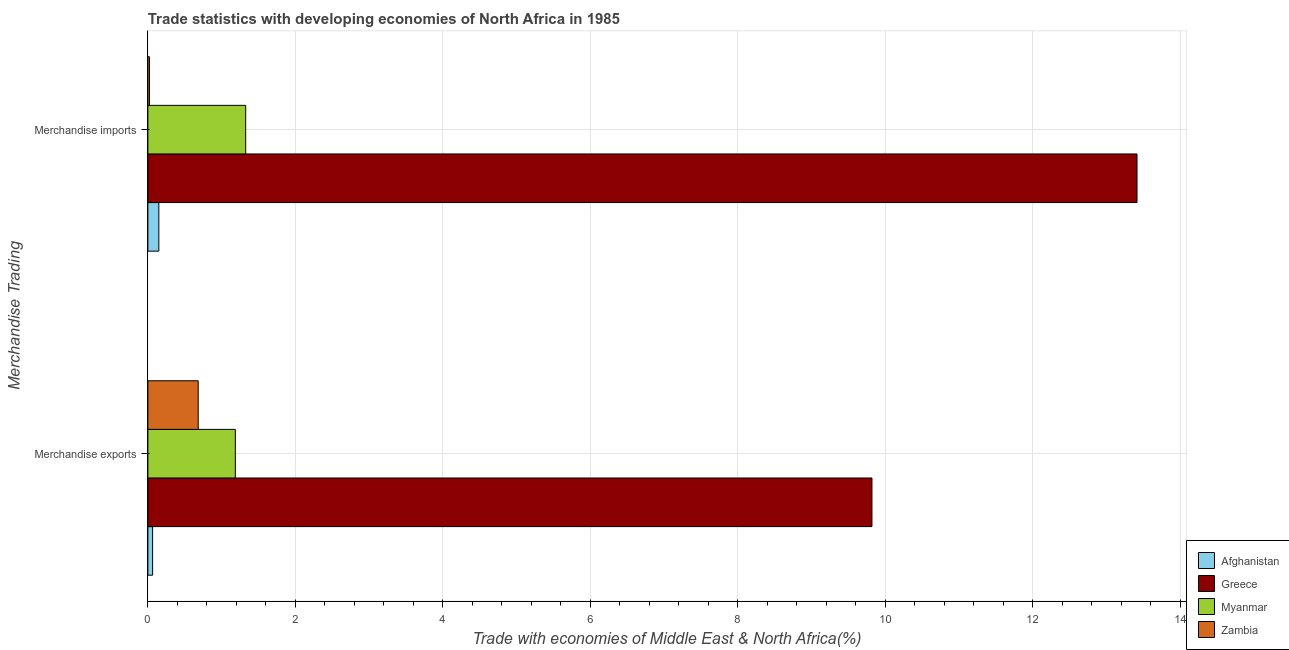How many groups of bars are there?
Give a very brief answer. 2. How many bars are there on the 2nd tick from the bottom?
Your answer should be very brief. 4. What is the label of the 1st group of bars from the top?
Provide a short and direct response. Merchandise imports. What is the merchandise imports in Zambia?
Make the answer very short. 0.02. Across all countries, what is the maximum merchandise imports?
Ensure brevity in your answer.  13.41. Across all countries, what is the minimum merchandise exports?
Your response must be concise. 0.06. In which country was the merchandise imports maximum?
Give a very brief answer. Greece. In which country was the merchandise imports minimum?
Provide a succinct answer. Zambia. What is the total merchandise imports in the graph?
Provide a short and direct response. 14.91. What is the difference between the merchandise imports in Myanmar and that in Greece?
Provide a succinct answer. -12.08. What is the difference between the merchandise exports in Greece and the merchandise imports in Afghanistan?
Your answer should be compact. 9.67. What is the average merchandise exports per country?
Offer a terse response. 2.94. What is the difference between the merchandise exports and merchandise imports in Afghanistan?
Offer a very short reply. -0.08. What is the ratio of the merchandise exports in Afghanistan to that in Greece?
Provide a succinct answer. 0.01. What does the 4th bar from the bottom in Merchandise exports represents?
Provide a short and direct response. Zambia. Does the graph contain grids?
Offer a very short reply. Yes. How many legend labels are there?
Offer a very short reply. 4. What is the title of the graph?
Your answer should be very brief. Trade statistics with developing economies of North Africa in 1985. What is the label or title of the X-axis?
Keep it short and to the point. Trade with economies of Middle East & North Africa(%). What is the label or title of the Y-axis?
Give a very brief answer. Merchandise Trading. What is the Trade with economies of Middle East & North Africa(%) in Afghanistan in Merchandise exports?
Provide a succinct answer. 0.06. What is the Trade with economies of Middle East & North Africa(%) in Greece in Merchandise exports?
Make the answer very short. 9.82. What is the Trade with economies of Middle East & North Africa(%) in Myanmar in Merchandise exports?
Your response must be concise. 1.19. What is the Trade with economies of Middle East & North Africa(%) of Zambia in Merchandise exports?
Your response must be concise. 0.68. What is the Trade with economies of Middle East & North Africa(%) in Afghanistan in Merchandise imports?
Your answer should be compact. 0.15. What is the Trade with economies of Middle East & North Africa(%) of Greece in Merchandise imports?
Provide a succinct answer. 13.41. What is the Trade with economies of Middle East & North Africa(%) of Myanmar in Merchandise imports?
Your response must be concise. 1.33. What is the Trade with economies of Middle East & North Africa(%) in Zambia in Merchandise imports?
Give a very brief answer. 0.02. Across all Merchandise Trading, what is the maximum Trade with economies of Middle East & North Africa(%) of Afghanistan?
Your response must be concise. 0.15. Across all Merchandise Trading, what is the maximum Trade with economies of Middle East & North Africa(%) of Greece?
Provide a short and direct response. 13.41. Across all Merchandise Trading, what is the maximum Trade with economies of Middle East & North Africa(%) in Myanmar?
Ensure brevity in your answer.  1.33. Across all Merchandise Trading, what is the maximum Trade with economies of Middle East & North Africa(%) of Zambia?
Provide a short and direct response. 0.68. Across all Merchandise Trading, what is the minimum Trade with economies of Middle East & North Africa(%) of Afghanistan?
Offer a terse response. 0.06. Across all Merchandise Trading, what is the minimum Trade with economies of Middle East & North Africa(%) of Greece?
Provide a short and direct response. 9.82. Across all Merchandise Trading, what is the minimum Trade with economies of Middle East & North Africa(%) in Myanmar?
Your response must be concise. 1.19. Across all Merchandise Trading, what is the minimum Trade with economies of Middle East & North Africa(%) in Zambia?
Offer a very short reply. 0.02. What is the total Trade with economies of Middle East & North Africa(%) of Afghanistan in the graph?
Offer a terse response. 0.21. What is the total Trade with economies of Middle East & North Africa(%) in Greece in the graph?
Keep it short and to the point. 23.23. What is the total Trade with economies of Middle East & North Africa(%) in Myanmar in the graph?
Offer a terse response. 2.51. What is the total Trade with economies of Middle East & North Africa(%) in Zambia in the graph?
Your answer should be very brief. 0.7. What is the difference between the Trade with economies of Middle East & North Africa(%) in Afghanistan in Merchandise exports and that in Merchandise imports?
Provide a succinct answer. -0.08. What is the difference between the Trade with economies of Middle East & North Africa(%) in Greece in Merchandise exports and that in Merchandise imports?
Offer a terse response. -3.59. What is the difference between the Trade with economies of Middle East & North Africa(%) of Myanmar in Merchandise exports and that in Merchandise imports?
Ensure brevity in your answer.  -0.14. What is the difference between the Trade with economies of Middle East & North Africa(%) of Zambia in Merchandise exports and that in Merchandise imports?
Your answer should be very brief. 0.66. What is the difference between the Trade with economies of Middle East & North Africa(%) in Afghanistan in Merchandise exports and the Trade with economies of Middle East & North Africa(%) in Greece in Merchandise imports?
Give a very brief answer. -13.35. What is the difference between the Trade with economies of Middle East & North Africa(%) of Afghanistan in Merchandise exports and the Trade with economies of Middle East & North Africa(%) of Myanmar in Merchandise imports?
Provide a short and direct response. -1.26. What is the difference between the Trade with economies of Middle East & North Africa(%) of Afghanistan in Merchandise exports and the Trade with economies of Middle East & North Africa(%) of Zambia in Merchandise imports?
Your response must be concise. 0.04. What is the difference between the Trade with economies of Middle East & North Africa(%) of Greece in Merchandise exports and the Trade with economies of Middle East & North Africa(%) of Myanmar in Merchandise imports?
Your answer should be compact. 8.49. What is the difference between the Trade with economies of Middle East & North Africa(%) of Greece in Merchandise exports and the Trade with economies of Middle East & North Africa(%) of Zambia in Merchandise imports?
Ensure brevity in your answer.  9.8. What is the difference between the Trade with economies of Middle East & North Africa(%) of Myanmar in Merchandise exports and the Trade with economies of Middle East & North Africa(%) of Zambia in Merchandise imports?
Make the answer very short. 1.16. What is the average Trade with economies of Middle East & North Africa(%) in Afghanistan per Merchandise Trading?
Keep it short and to the point. 0.11. What is the average Trade with economies of Middle East & North Africa(%) of Greece per Merchandise Trading?
Your answer should be compact. 11.61. What is the average Trade with economies of Middle East & North Africa(%) of Myanmar per Merchandise Trading?
Offer a terse response. 1.26. What is the average Trade with economies of Middle East & North Africa(%) of Zambia per Merchandise Trading?
Provide a succinct answer. 0.35. What is the difference between the Trade with economies of Middle East & North Africa(%) of Afghanistan and Trade with economies of Middle East & North Africa(%) of Greece in Merchandise exports?
Provide a succinct answer. -9.75. What is the difference between the Trade with economies of Middle East & North Africa(%) of Afghanistan and Trade with economies of Middle East & North Africa(%) of Myanmar in Merchandise exports?
Offer a very short reply. -1.12. What is the difference between the Trade with economies of Middle East & North Africa(%) of Afghanistan and Trade with economies of Middle East & North Africa(%) of Zambia in Merchandise exports?
Offer a terse response. -0.62. What is the difference between the Trade with economies of Middle East & North Africa(%) of Greece and Trade with economies of Middle East & North Africa(%) of Myanmar in Merchandise exports?
Ensure brevity in your answer.  8.63. What is the difference between the Trade with economies of Middle East & North Africa(%) in Greece and Trade with economies of Middle East & North Africa(%) in Zambia in Merchandise exports?
Keep it short and to the point. 9.13. What is the difference between the Trade with economies of Middle East & North Africa(%) in Myanmar and Trade with economies of Middle East & North Africa(%) in Zambia in Merchandise exports?
Offer a terse response. 0.5. What is the difference between the Trade with economies of Middle East & North Africa(%) of Afghanistan and Trade with economies of Middle East & North Africa(%) of Greece in Merchandise imports?
Provide a short and direct response. -13.26. What is the difference between the Trade with economies of Middle East & North Africa(%) of Afghanistan and Trade with economies of Middle East & North Africa(%) of Myanmar in Merchandise imports?
Your response must be concise. -1.18. What is the difference between the Trade with economies of Middle East & North Africa(%) in Afghanistan and Trade with economies of Middle East & North Africa(%) in Zambia in Merchandise imports?
Offer a terse response. 0.13. What is the difference between the Trade with economies of Middle East & North Africa(%) in Greece and Trade with economies of Middle East & North Africa(%) in Myanmar in Merchandise imports?
Ensure brevity in your answer.  12.08. What is the difference between the Trade with economies of Middle East & North Africa(%) in Greece and Trade with economies of Middle East & North Africa(%) in Zambia in Merchandise imports?
Provide a short and direct response. 13.39. What is the difference between the Trade with economies of Middle East & North Africa(%) of Myanmar and Trade with economies of Middle East & North Africa(%) of Zambia in Merchandise imports?
Your answer should be very brief. 1.3. What is the ratio of the Trade with economies of Middle East & North Africa(%) of Afghanistan in Merchandise exports to that in Merchandise imports?
Offer a terse response. 0.43. What is the ratio of the Trade with economies of Middle East & North Africa(%) in Greece in Merchandise exports to that in Merchandise imports?
Your answer should be very brief. 0.73. What is the ratio of the Trade with economies of Middle East & North Africa(%) in Myanmar in Merchandise exports to that in Merchandise imports?
Your answer should be compact. 0.89. What is the ratio of the Trade with economies of Middle East & North Africa(%) of Zambia in Merchandise exports to that in Merchandise imports?
Ensure brevity in your answer.  31.85. What is the difference between the highest and the second highest Trade with economies of Middle East & North Africa(%) of Afghanistan?
Ensure brevity in your answer.  0.08. What is the difference between the highest and the second highest Trade with economies of Middle East & North Africa(%) of Greece?
Make the answer very short. 3.59. What is the difference between the highest and the second highest Trade with economies of Middle East & North Africa(%) in Myanmar?
Offer a very short reply. 0.14. What is the difference between the highest and the second highest Trade with economies of Middle East & North Africa(%) in Zambia?
Keep it short and to the point. 0.66. What is the difference between the highest and the lowest Trade with economies of Middle East & North Africa(%) of Afghanistan?
Ensure brevity in your answer.  0.08. What is the difference between the highest and the lowest Trade with economies of Middle East & North Africa(%) of Greece?
Make the answer very short. 3.59. What is the difference between the highest and the lowest Trade with economies of Middle East & North Africa(%) in Myanmar?
Your answer should be very brief. 0.14. What is the difference between the highest and the lowest Trade with economies of Middle East & North Africa(%) of Zambia?
Offer a terse response. 0.66. 